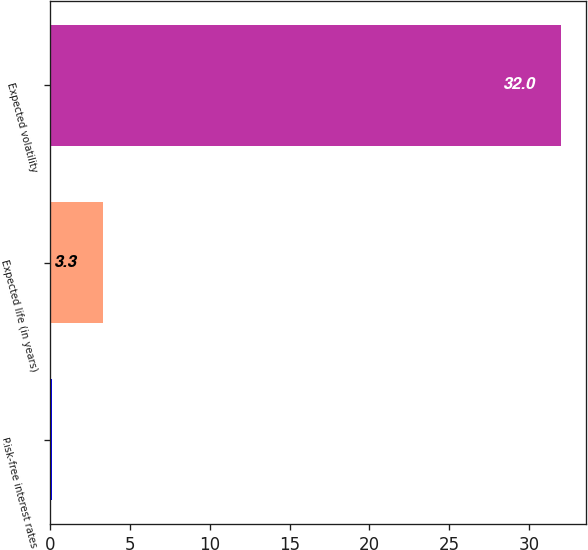Convert chart. <chart><loc_0><loc_0><loc_500><loc_500><bar_chart><fcel>Risk-free interest rates<fcel>Expected life (in years)<fcel>Expected volatility<nl><fcel>0.11<fcel>3.3<fcel>32<nl></chart> 